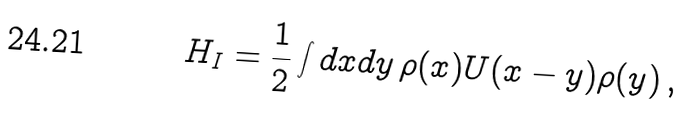<formula> <loc_0><loc_0><loc_500><loc_500>H _ { I } = \frac { 1 } { 2 } \int d x d y \, \rho ( x ) U ( x - y ) \rho ( y ) \, ,</formula> 